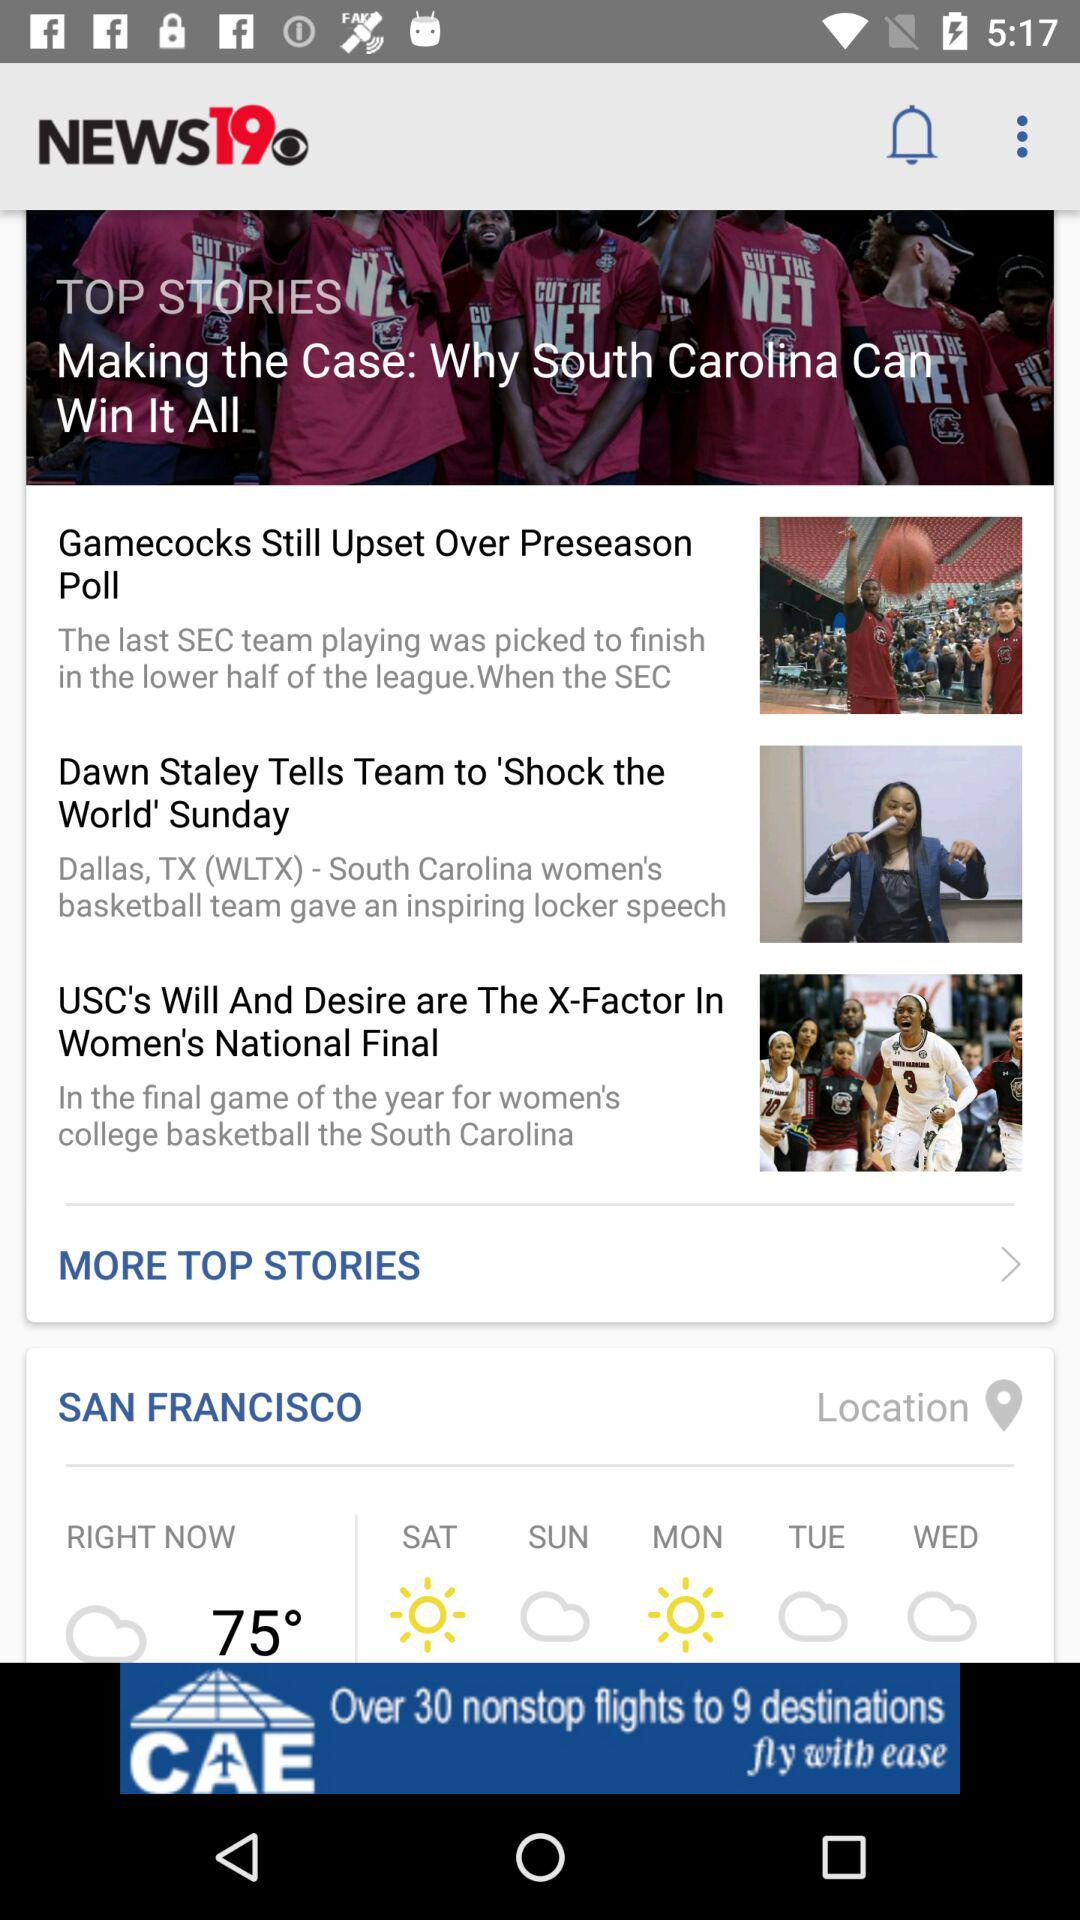What will be the weather on Sunday? The weather on Sunday will be cloudy. 